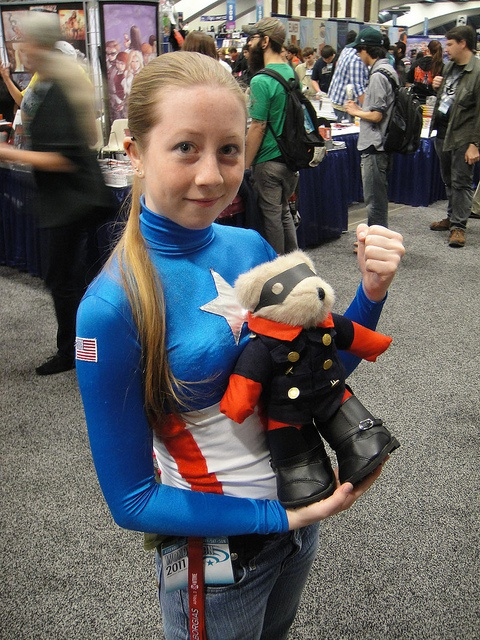Describe the objects in this image and their specific colors. I can see people in gray, black, navy, blue, and tan tones, teddy bear in gray, black, beige, and red tones, people in gray, black, and tan tones, people in gray, black, darkgreen, and maroon tones, and people in gray and black tones in this image. 